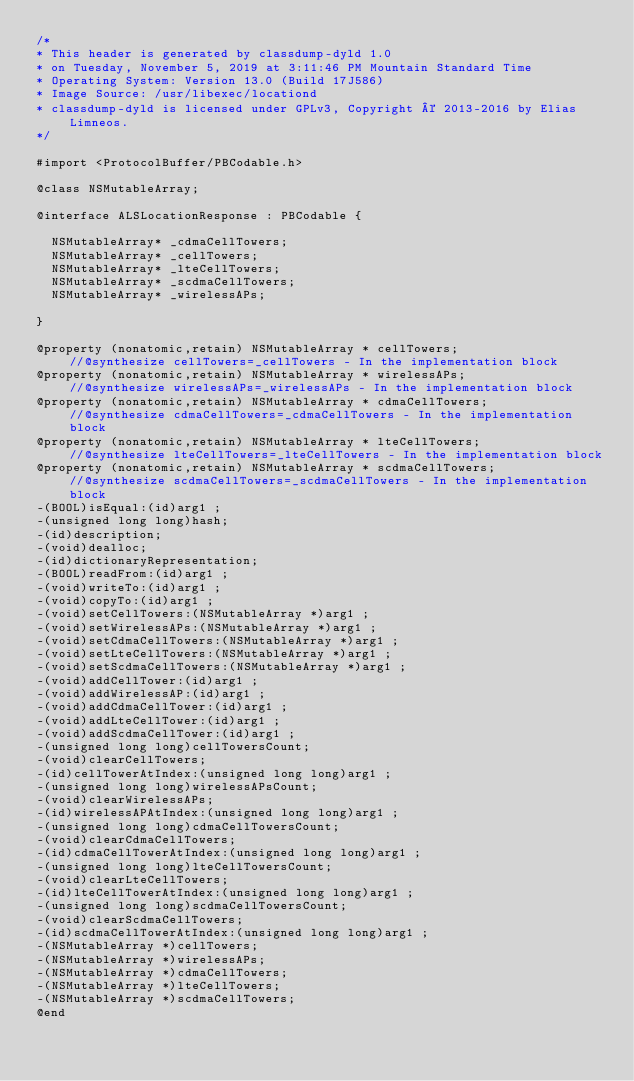<code> <loc_0><loc_0><loc_500><loc_500><_C_>/*
* This header is generated by classdump-dyld 1.0
* on Tuesday, November 5, 2019 at 3:11:46 PM Mountain Standard Time
* Operating System: Version 13.0 (Build 17J586)
* Image Source: /usr/libexec/locationd
* classdump-dyld is licensed under GPLv3, Copyright © 2013-2016 by Elias Limneos.
*/

#import <ProtocolBuffer/PBCodable.h>

@class NSMutableArray;

@interface ALSLocationResponse : PBCodable {

	NSMutableArray* _cdmaCellTowers;
	NSMutableArray* _cellTowers;
	NSMutableArray* _lteCellTowers;
	NSMutableArray* _scdmaCellTowers;
	NSMutableArray* _wirelessAPs;

}

@property (nonatomic,retain) NSMutableArray * cellTowers;                   //@synthesize cellTowers=_cellTowers - In the implementation block
@property (nonatomic,retain) NSMutableArray * wirelessAPs;                  //@synthesize wirelessAPs=_wirelessAPs - In the implementation block
@property (nonatomic,retain) NSMutableArray * cdmaCellTowers;               //@synthesize cdmaCellTowers=_cdmaCellTowers - In the implementation block
@property (nonatomic,retain) NSMutableArray * lteCellTowers;                //@synthesize lteCellTowers=_lteCellTowers - In the implementation block
@property (nonatomic,retain) NSMutableArray * scdmaCellTowers;              //@synthesize scdmaCellTowers=_scdmaCellTowers - In the implementation block
-(BOOL)isEqual:(id)arg1 ;
-(unsigned long long)hash;
-(id)description;
-(void)dealloc;
-(id)dictionaryRepresentation;
-(BOOL)readFrom:(id)arg1 ;
-(void)writeTo:(id)arg1 ;
-(void)copyTo:(id)arg1 ;
-(void)setCellTowers:(NSMutableArray *)arg1 ;
-(void)setWirelessAPs:(NSMutableArray *)arg1 ;
-(void)setCdmaCellTowers:(NSMutableArray *)arg1 ;
-(void)setLteCellTowers:(NSMutableArray *)arg1 ;
-(void)setScdmaCellTowers:(NSMutableArray *)arg1 ;
-(void)addCellTower:(id)arg1 ;
-(void)addWirelessAP:(id)arg1 ;
-(void)addCdmaCellTower:(id)arg1 ;
-(void)addLteCellTower:(id)arg1 ;
-(void)addScdmaCellTower:(id)arg1 ;
-(unsigned long long)cellTowersCount;
-(void)clearCellTowers;
-(id)cellTowerAtIndex:(unsigned long long)arg1 ;
-(unsigned long long)wirelessAPsCount;
-(void)clearWirelessAPs;
-(id)wirelessAPAtIndex:(unsigned long long)arg1 ;
-(unsigned long long)cdmaCellTowersCount;
-(void)clearCdmaCellTowers;
-(id)cdmaCellTowerAtIndex:(unsigned long long)arg1 ;
-(unsigned long long)lteCellTowersCount;
-(void)clearLteCellTowers;
-(id)lteCellTowerAtIndex:(unsigned long long)arg1 ;
-(unsigned long long)scdmaCellTowersCount;
-(void)clearScdmaCellTowers;
-(id)scdmaCellTowerAtIndex:(unsigned long long)arg1 ;
-(NSMutableArray *)cellTowers;
-(NSMutableArray *)wirelessAPs;
-(NSMutableArray *)cdmaCellTowers;
-(NSMutableArray *)lteCellTowers;
-(NSMutableArray *)scdmaCellTowers;
@end

</code> 